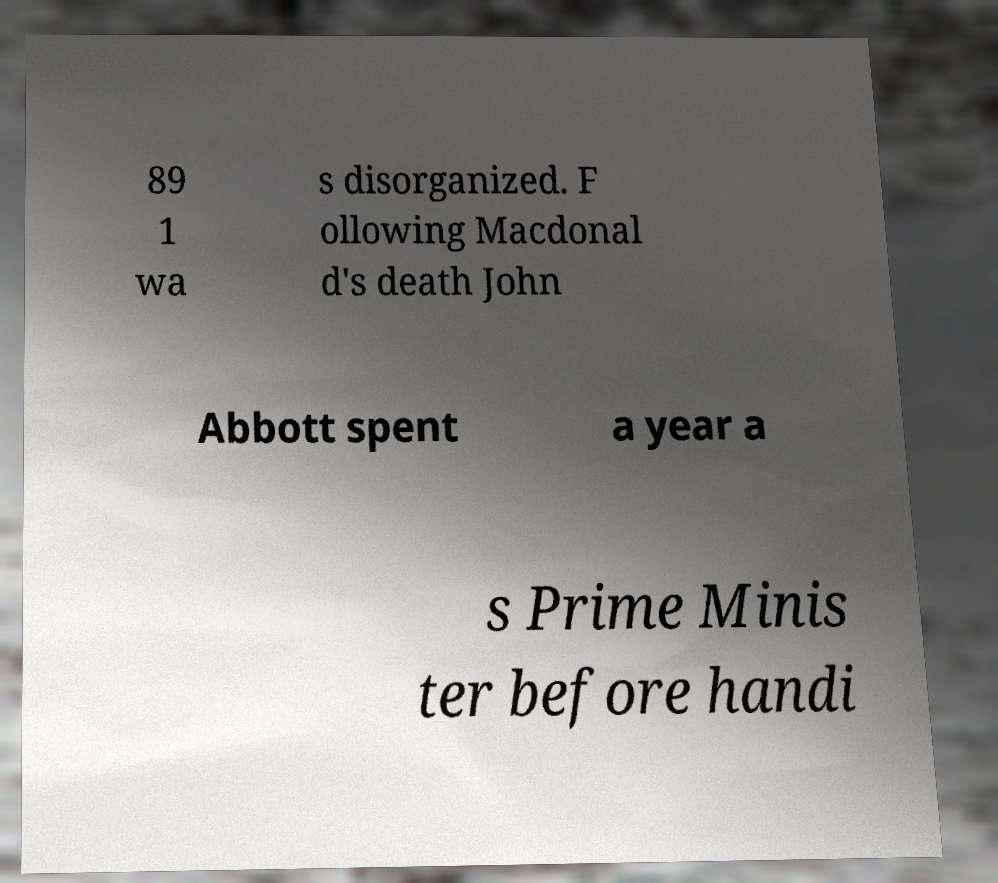Please read and relay the text visible in this image. What does it say? 89 1 wa s disorganized. F ollowing Macdonal d's death John Abbott spent a year a s Prime Minis ter before handi 